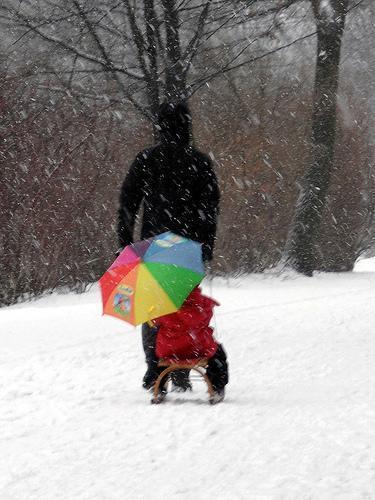How many people are in the picture?
Give a very brief answer. 2. 